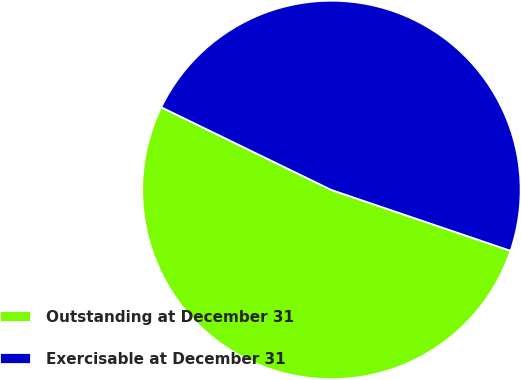<chart> <loc_0><loc_0><loc_500><loc_500><pie_chart><fcel>Outstanding at December 31<fcel>Exercisable at December 31<nl><fcel>51.99%<fcel>48.01%<nl></chart> 